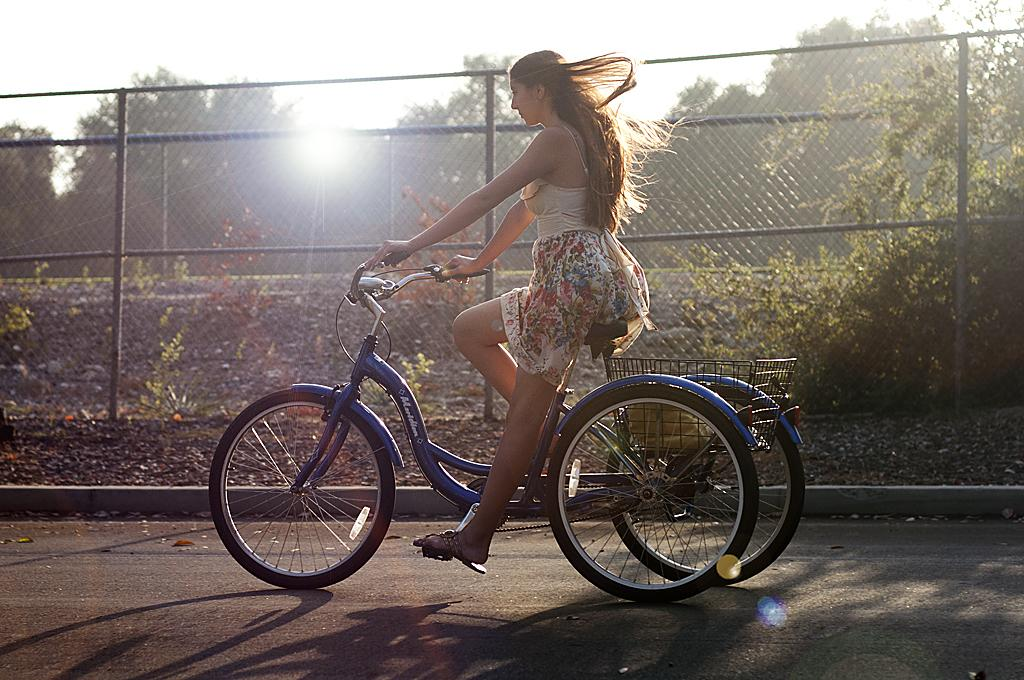Who is the main subject in the image? There is a woman in the image. What is the woman doing in the image? The woman is riding a bicycle. What can be seen in the background of the image? There is a metal fence, trees, and the sky visible in the background of the image. Can the sun be seen in the image? Yes, the sun is observable in the sky. What type of leather is being used to make the pin visible in the image? There is no pin or leather present in the image. 